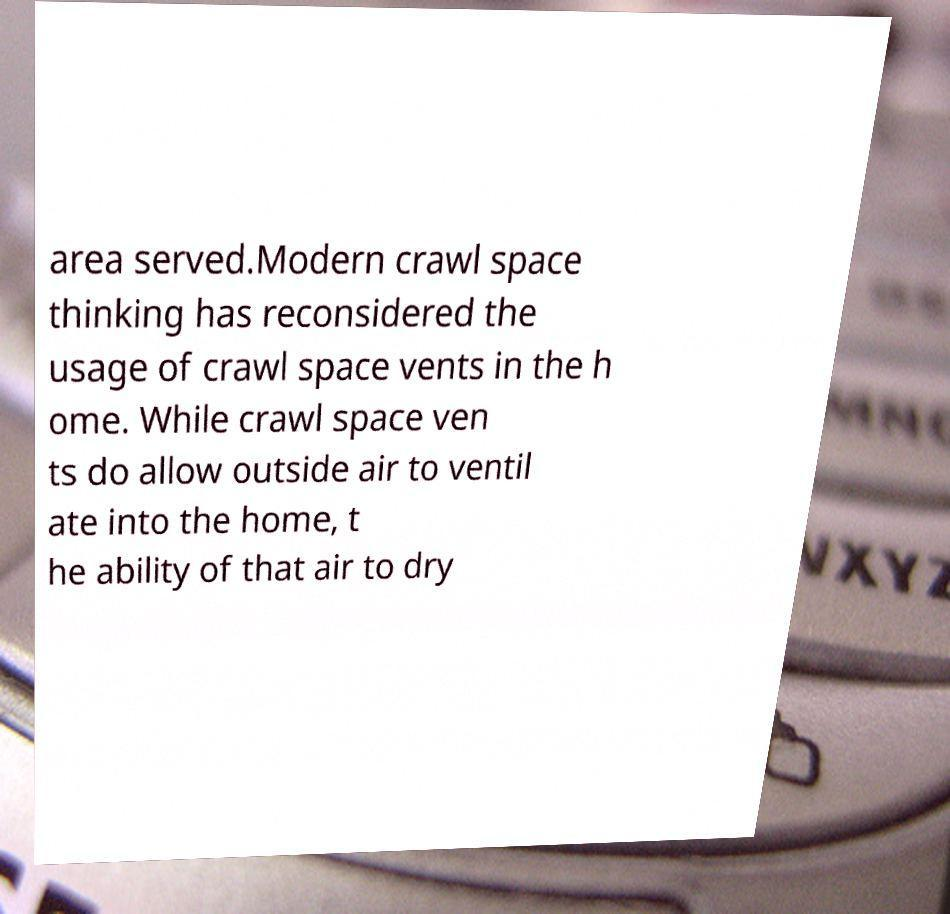I need the written content from this picture converted into text. Can you do that? area served.Modern crawl space thinking has reconsidered the usage of crawl space vents in the h ome. While crawl space ven ts do allow outside air to ventil ate into the home, t he ability of that air to dry 